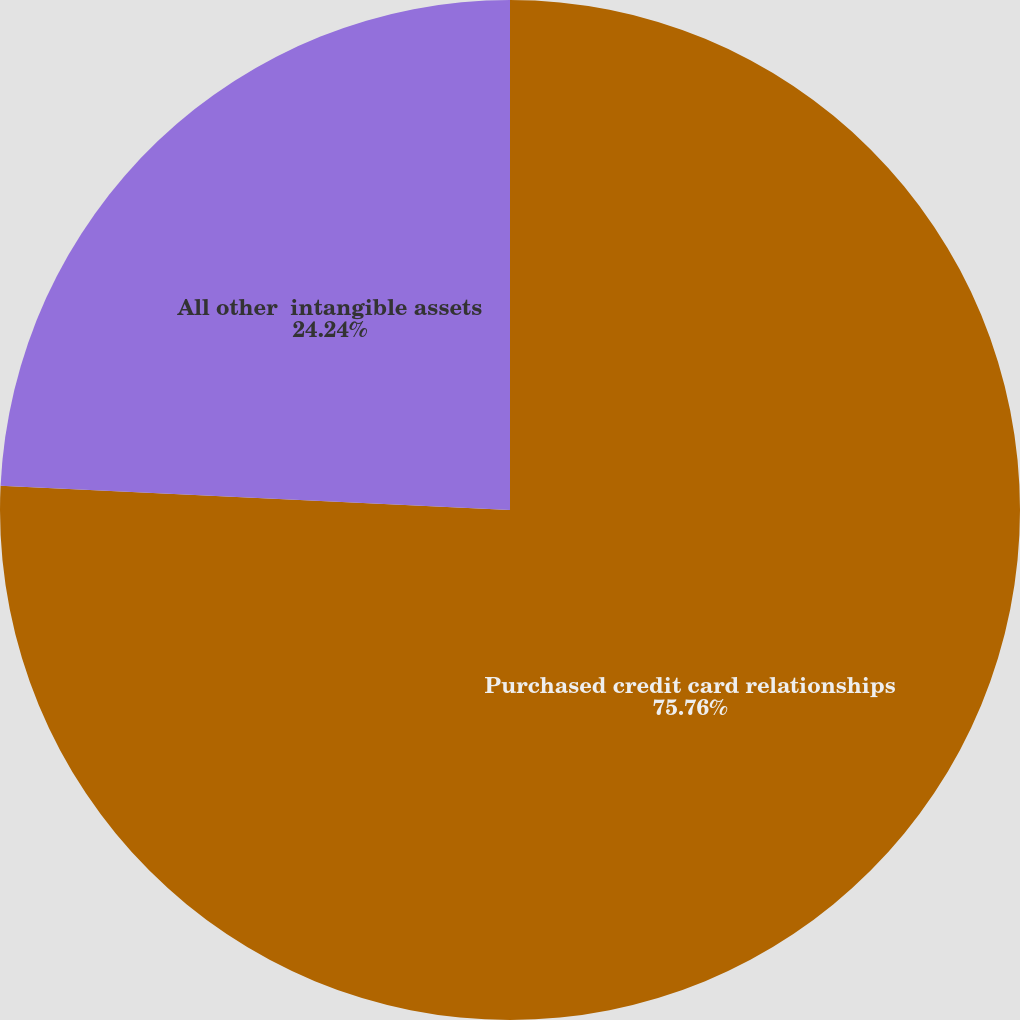Convert chart to OTSL. <chart><loc_0><loc_0><loc_500><loc_500><pie_chart><fcel>Purchased credit card relationships<fcel>All other  intangible assets<nl><fcel>75.76%<fcel>24.24%<nl></chart> 